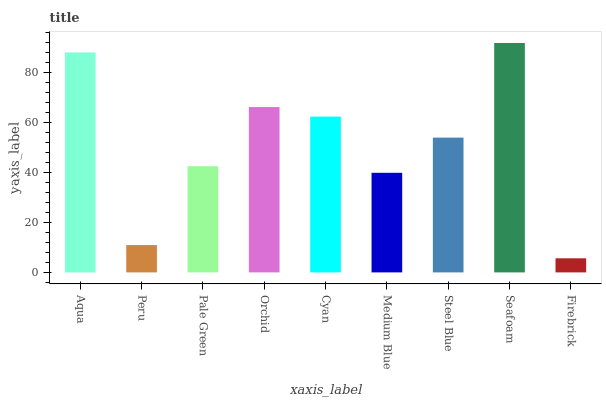Is Firebrick the minimum?
Answer yes or no. Yes. Is Seafoam the maximum?
Answer yes or no. Yes. Is Peru the minimum?
Answer yes or no. No. Is Peru the maximum?
Answer yes or no. No. Is Aqua greater than Peru?
Answer yes or no. Yes. Is Peru less than Aqua?
Answer yes or no. Yes. Is Peru greater than Aqua?
Answer yes or no. No. Is Aqua less than Peru?
Answer yes or no. No. Is Steel Blue the high median?
Answer yes or no. Yes. Is Steel Blue the low median?
Answer yes or no. Yes. Is Seafoam the high median?
Answer yes or no. No. Is Firebrick the low median?
Answer yes or no. No. 